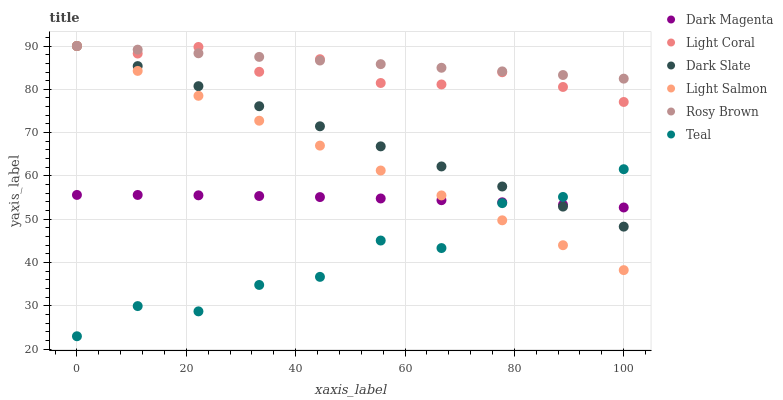Does Teal have the minimum area under the curve?
Answer yes or no. Yes. Does Rosy Brown have the maximum area under the curve?
Answer yes or no. Yes. Does Dark Magenta have the minimum area under the curve?
Answer yes or no. No. Does Dark Magenta have the maximum area under the curve?
Answer yes or no. No. Is Light Salmon the smoothest?
Answer yes or no. Yes. Is Teal the roughest?
Answer yes or no. Yes. Is Dark Magenta the smoothest?
Answer yes or no. No. Is Dark Magenta the roughest?
Answer yes or no. No. Does Teal have the lowest value?
Answer yes or no. Yes. Does Dark Magenta have the lowest value?
Answer yes or no. No. Does Dark Slate have the highest value?
Answer yes or no. Yes. Does Dark Magenta have the highest value?
Answer yes or no. No. Is Teal less than Rosy Brown?
Answer yes or no. Yes. Is Rosy Brown greater than Dark Magenta?
Answer yes or no. Yes. Does Dark Slate intersect Dark Magenta?
Answer yes or no. Yes. Is Dark Slate less than Dark Magenta?
Answer yes or no. No. Is Dark Slate greater than Dark Magenta?
Answer yes or no. No. Does Teal intersect Rosy Brown?
Answer yes or no. No. 